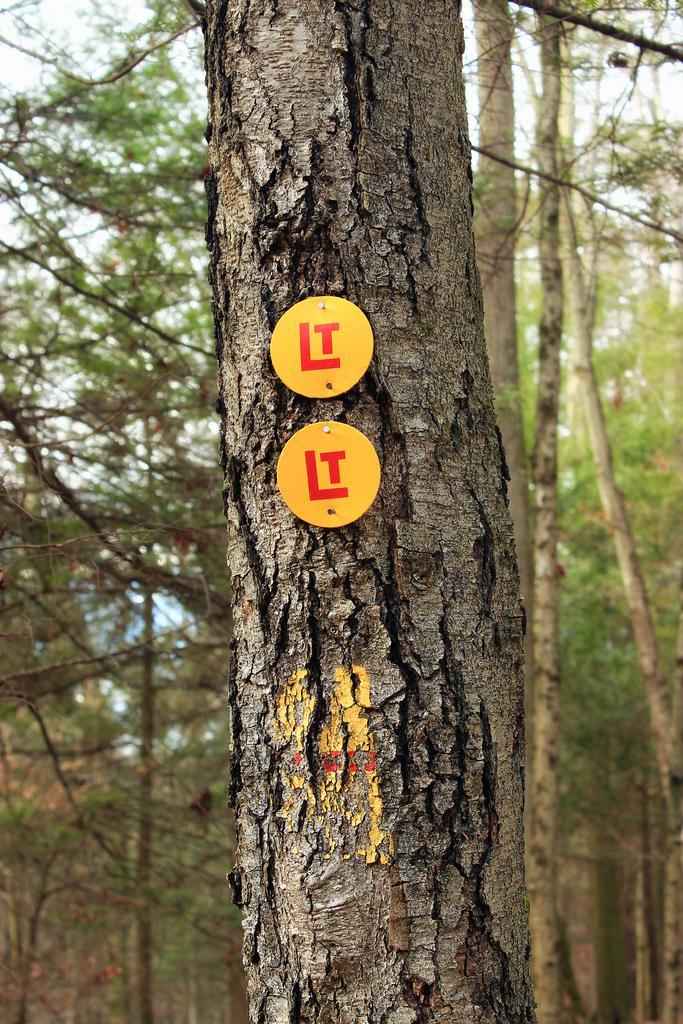Could you give a brief overview of what you see in this image? In this image, there are a few trees. We can see some yellow colored objects with text on the branch of one of the trees. We can also see the sky. 